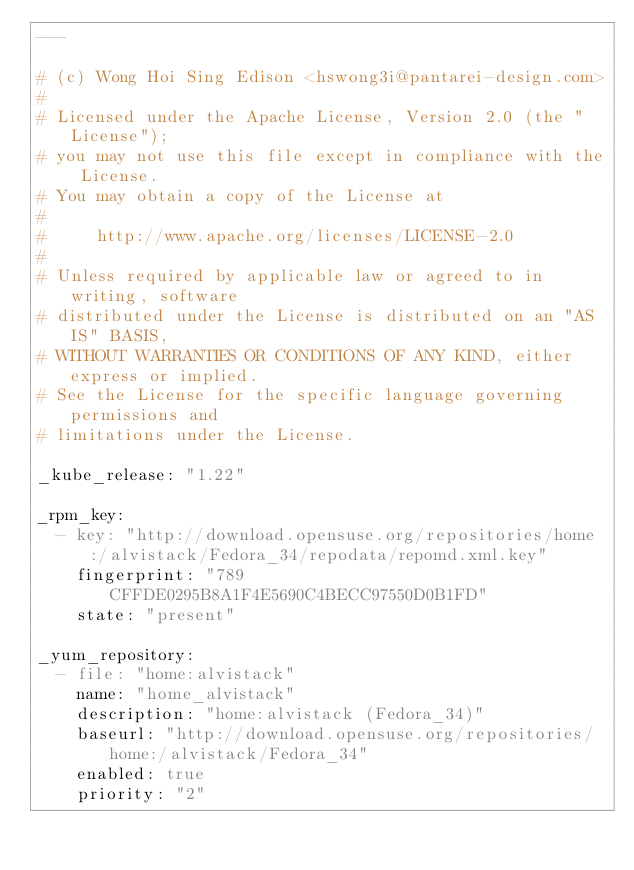Convert code to text. <code><loc_0><loc_0><loc_500><loc_500><_YAML_>---

# (c) Wong Hoi Sing Edison <hswong3i@pantarei-design.com>
#
# Licensed under the Apache License, Version 2.0 (the "License");
# you may not use this file except in compliance with the License.
# You may obtain a copy of the License at
#
#     http://www.apache.org/licenses/LICENSE-2.0
#
# Unless required by applicable law or agreed to in writing, software
# distributed under the License is distributed on an "AS IS" BASIS,
# WITHOUT WARRANTIES OR CONDITIONS OF ANY KIND, either express or implied.
# See the License for the specific language governing permissions and
# limitations under the License.

_kube_release: "1.22"

_rpm_key:
  - key: "http://download.opensuse.org/repositories/home:/alvistack/Fedora_34/repodata/repomd.xml.key"
    fingerprint: "789CFFDE0295B8A1F4E5690C4BECC97550D0B1FD"
    state: "present"

_yum_repository:
  - file: "home:alvistack"
    name: "home_alvistack"
    description: "home:alvistack (Fedora_34)"
    baseurl: "http://download.opensuse.org/repositories/home:/alvistack/Fedora_34"
    enabled: true
    priority: "2"</code> 